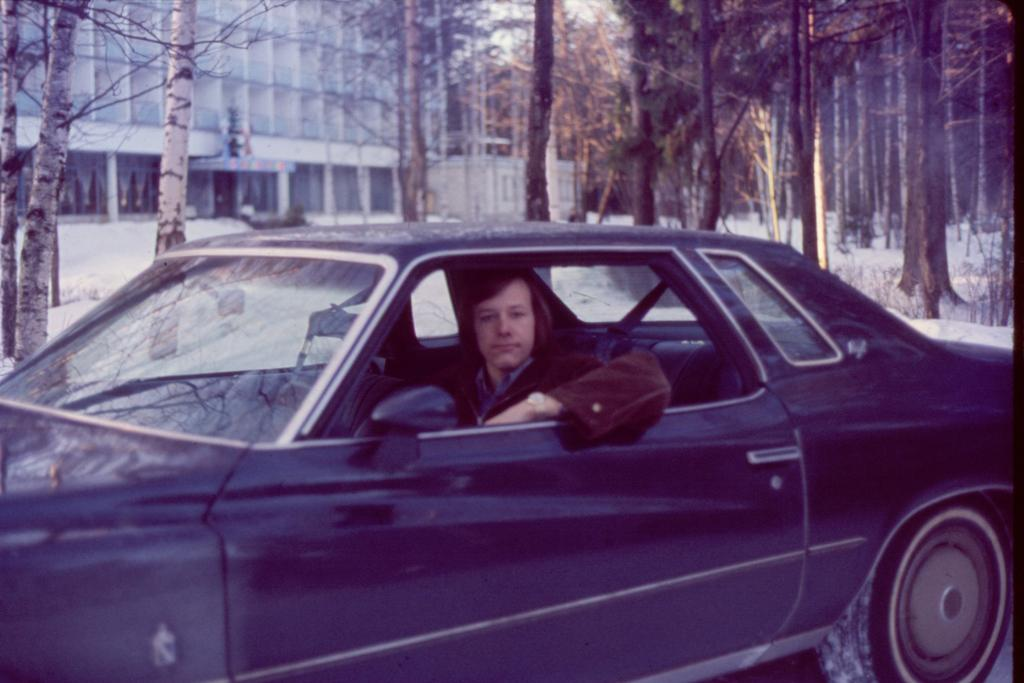What is the person in the image doing? There is a person sitting in a car in the image. What can be seen in the background of the image? There are buildings and trees in the image. What is the weather like in the image? There is snow visible in the image, indicating a cold or wintery environment. What is the rate of liquid evaporation in the image? There is no mention of liquid or evaporation in the image, so it is not possible to determine the rate of liquid evaporation. 